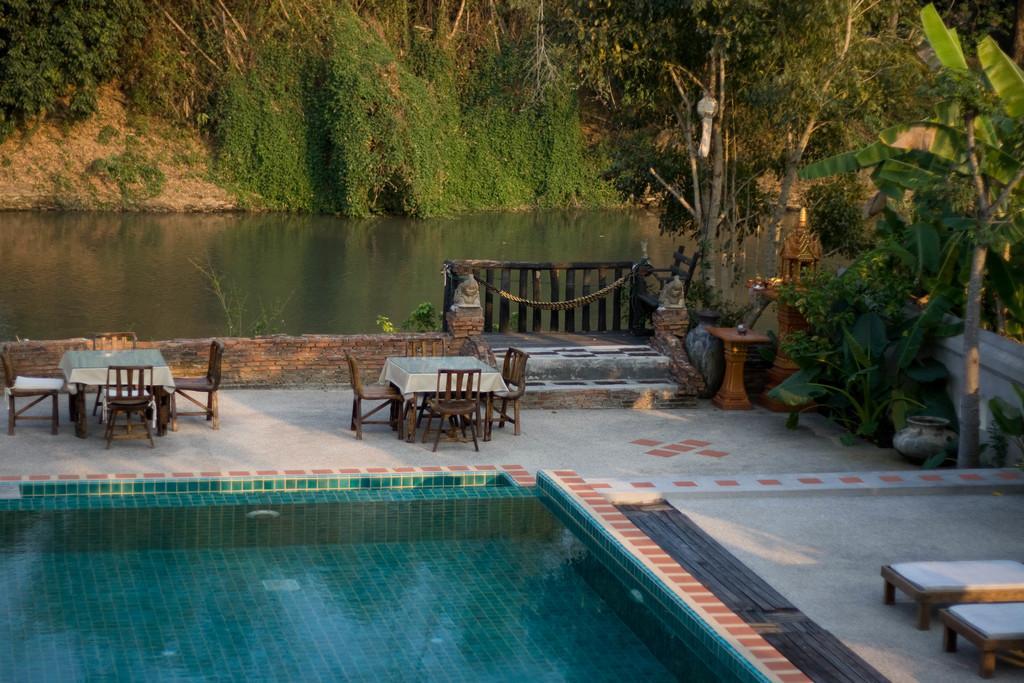In one or two sentences, can you explain what this image depicts? In the foreground of this image, there is a swimming pool, few benches like objects on the right. In the middle, there are tables, chairs, few plants, trees and a railing. In the background, there is water and the greenery. 